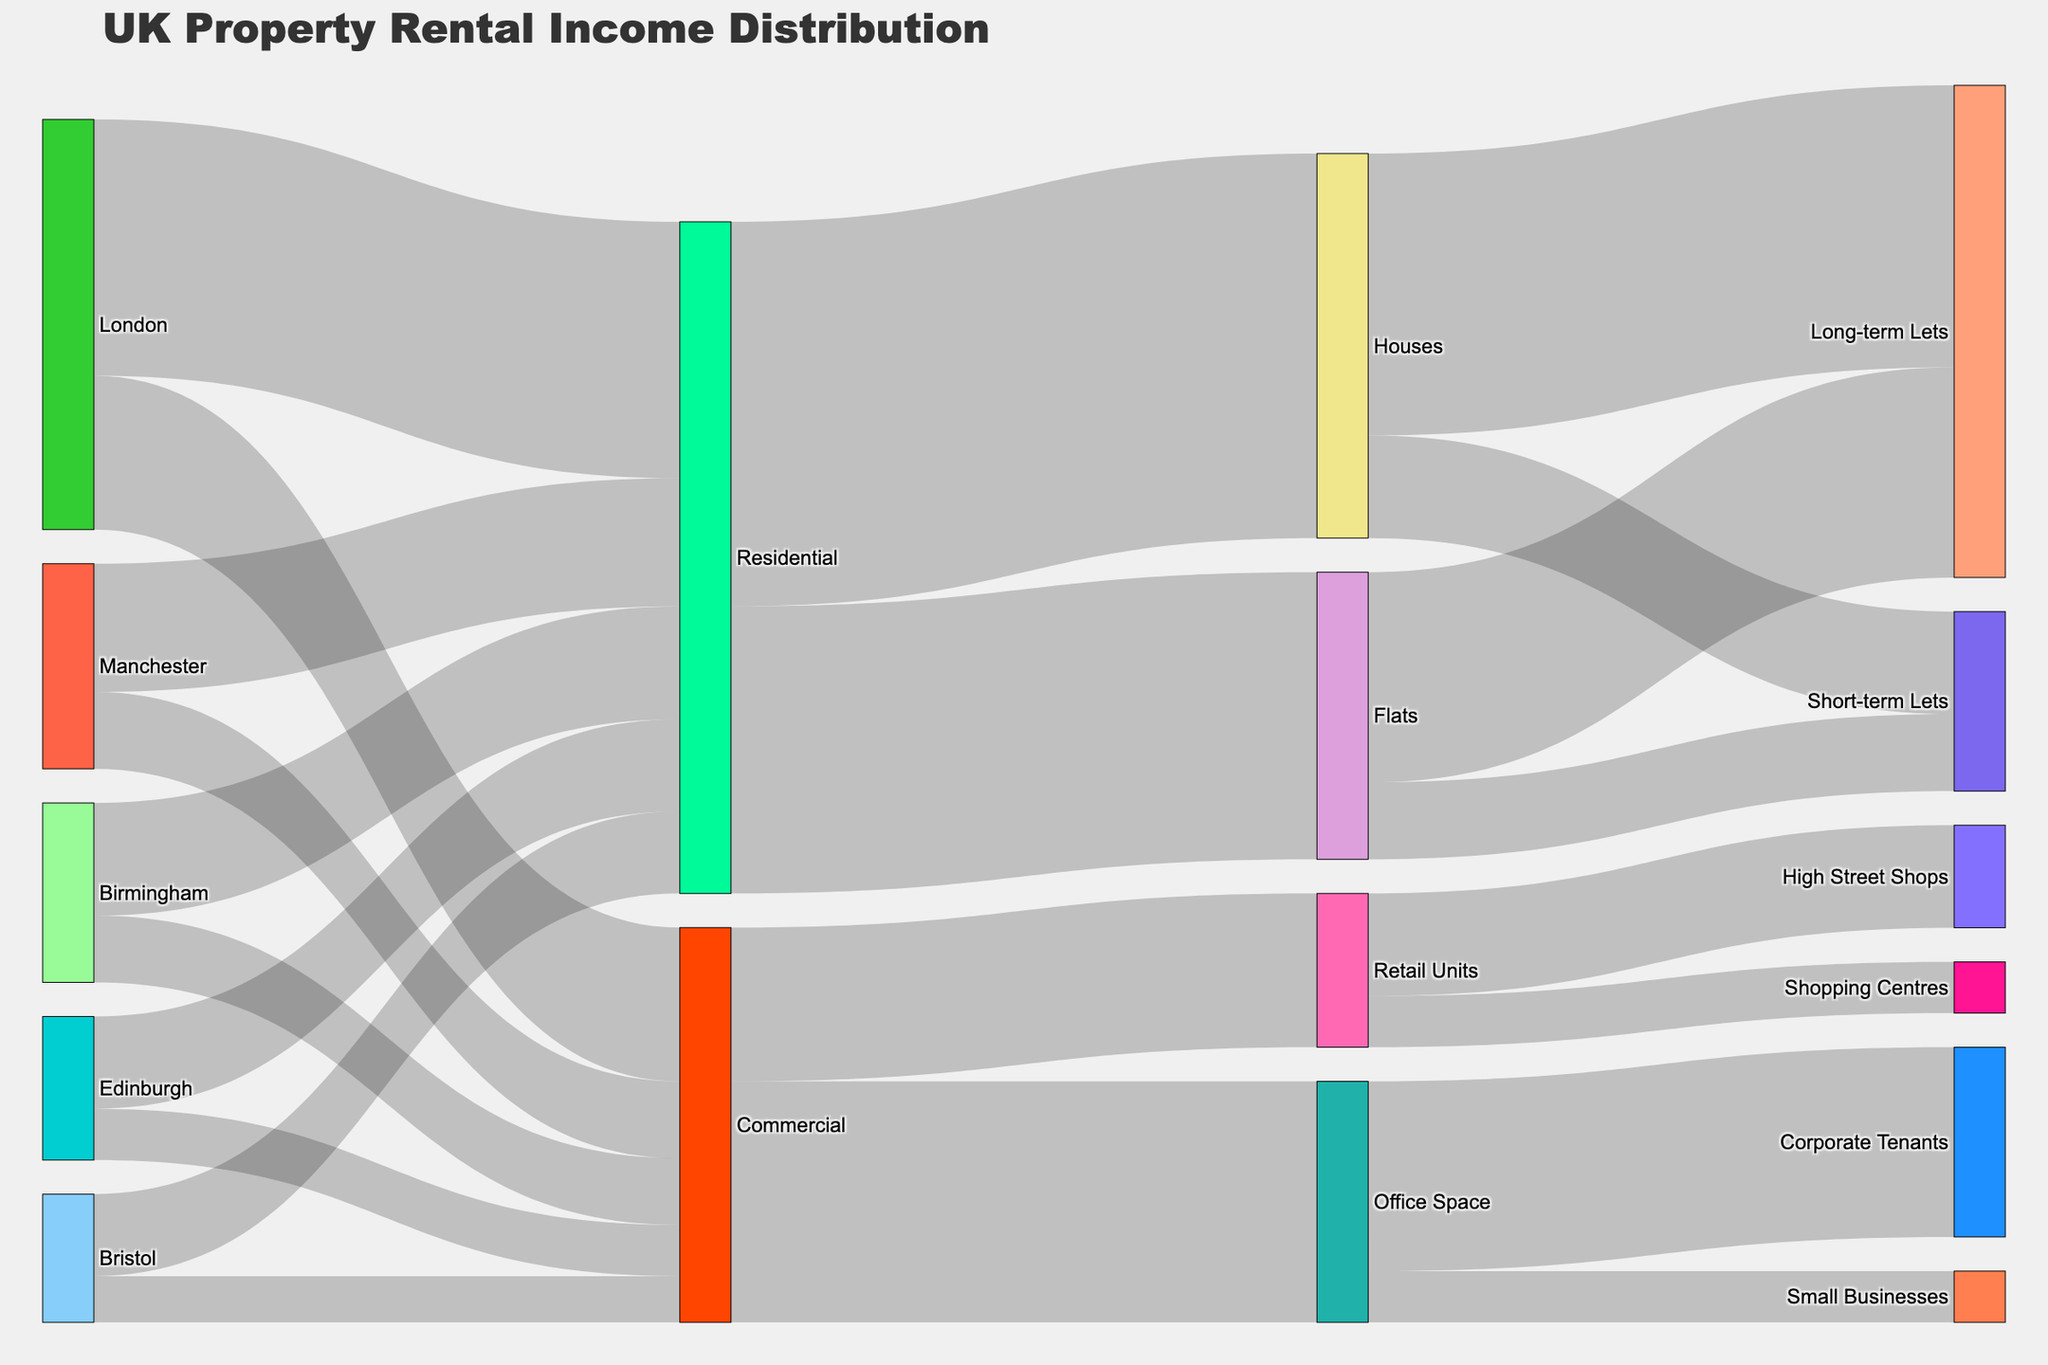1. Which city generates the highest rental income from residential properties? According to the diagram, London generates the highest rental income for residential properties at £5 million.
Answer: London 2. How does the rental income from Bristol's commercial properties compare to Manchester's commercial properties? The figure shows that Bristol earns £900,000 from commercial properties whereas Manchester earns £1.5 million, making Manchester's commercial property income higher.
Answer: Manchester has higher commercial income 3. What is the total rental income earned from residential properties across all cities? Summing up the rental income from residential properties across all cities: London (£5,000,000) + Manchester (£2,500,000) + Birmingham (£2,200,000) + Edinburgh (£1,800,000) + Bristol (£1,600,000). Total = £13,100,000.
Answer: £13,100,000 4. Compare the income from houses and flats in the residential category. The diagram shows that the income from houses is £7,500,000 and from flats is £5,600,000 in the residential category. Houses generate more income than flats.
Answer: Houses 5. What type of properties generate the least rental income overall in the chart? By examining all the flows, it's evident that Retail Units generate the least overall rental income, totaling £3,000,000 (£2,000,000 from High Street Shops and £1,000,000 from Shopping Centres).
Answer: Retail Units 6. What is the total rental income from corporate tenants and small businesses in office spaces? According to the Sankey diagram, corporate tenants generate £3,700,000 and small businesses generate £1,000,000 from office spaces. Total income = £3,700,000 + £1,000,000 = £4,700,000.
Answer: £4,700,000 7. What is the combined rental income from long-term and short-term lets in flats? The diagram indicates long-term lets in flats generate £4,100,000, while short-term lets generate £1,500,000. Combined income = £4,100,000 + £1,500,000 = £5,600,000.
Answer: £5,600,000 8. Which type of commercial property generates more income, office space or retail units? According to the figure, office spaces generate £4,700,000, while retail units generate £3,000,000. Thus, office spaces generate more income.
Answer: Office Space 9. How much more rental income is generated by long-term lets in houses compared to short-term lets in houses? The diagram shows long-term lets in houses generate £5,500,000, while short-term lets generate £2,000,000. The difference is £5,500,000 - £2,000,000 = £3,500,000.
Answer: £3,500,000 